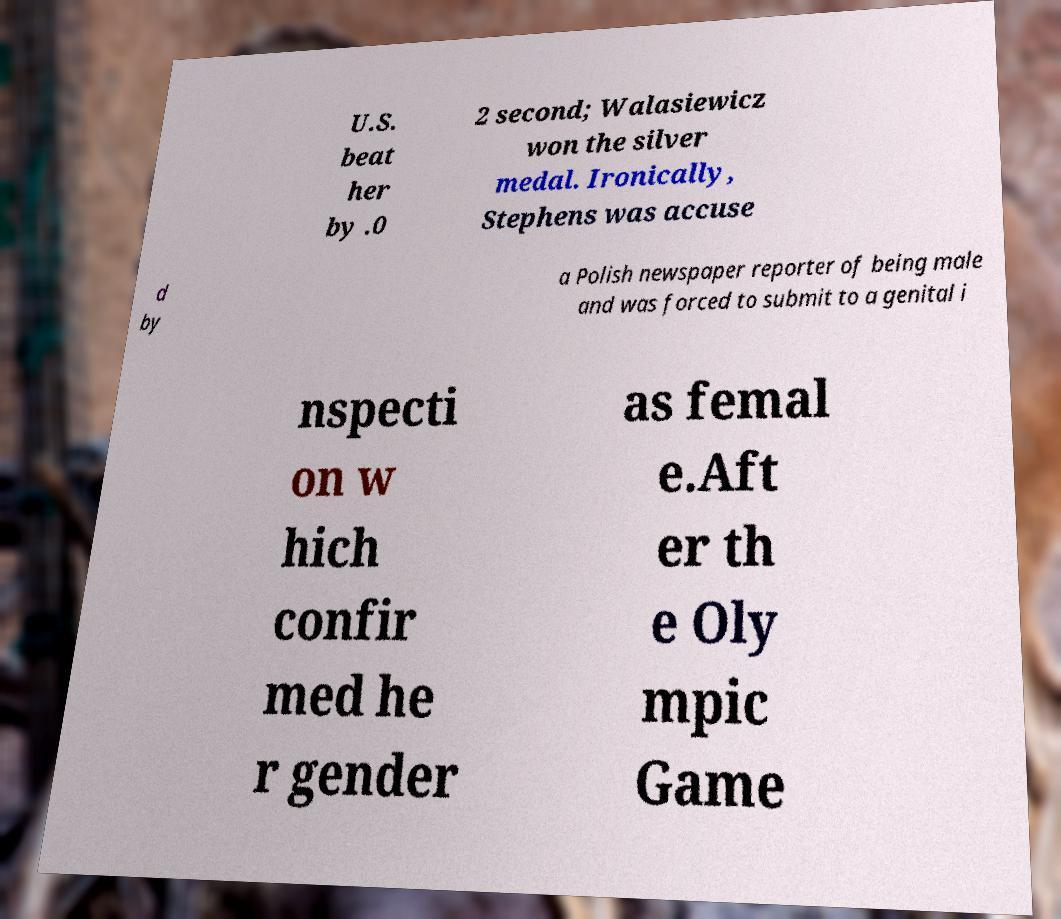Could you assist in decoding the text presented in this image and type it out clearly? U.S. beat her by .0 2 second; Walasiewicz won the silver medal. Ironically, Stephens was accuse d by a Polish newspaper reporter of being male and was forced to submit to a genital i nspecti on w hich confir med he r gender as femal e.Aft er th e Oly mpic Game 